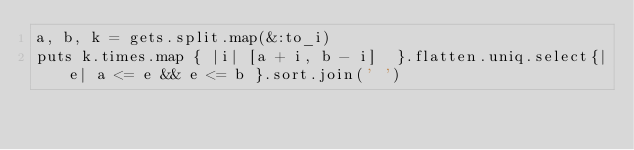<code> <loc_0><loc_0><loc_500><loc_500><_Ruby_>a, b, k = gets.split.map(&:to_i)
puts k.times.map { |i| [a + i, b - i]  }.flatten.uniq.select{|e| a <= e && e <= b }.sort.join(' ')</code> 